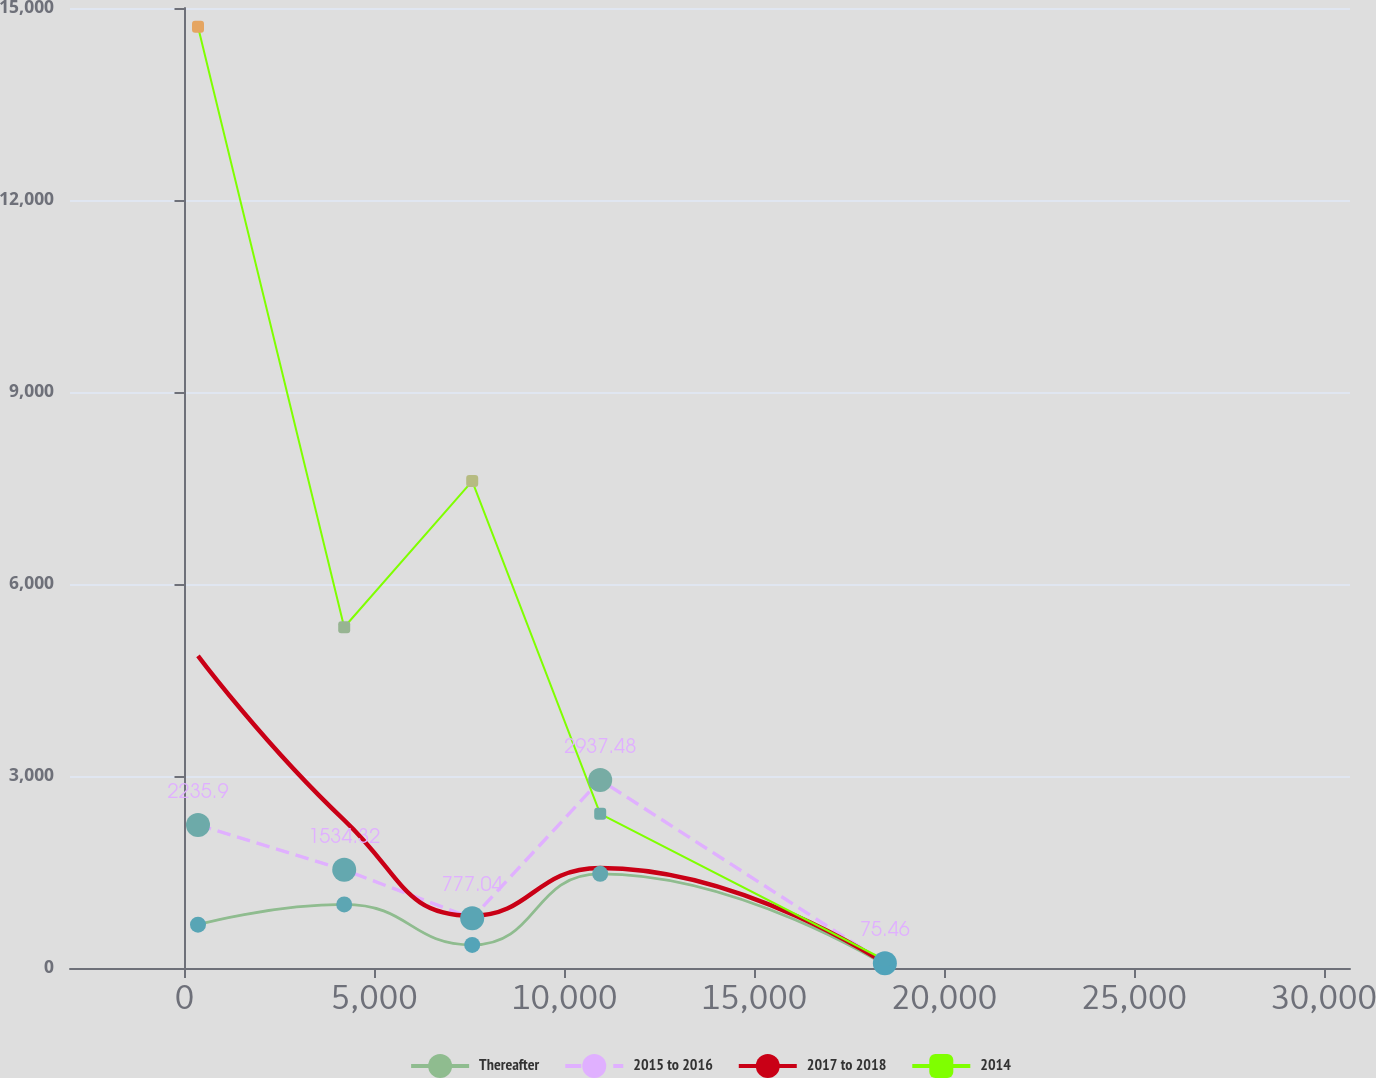<chart> <loc_0><loc_0><loc_500><loc_500><line_chart><ecel><fcel>Thereafter<fcel>2015 to 2016<fcel>2017 to 2018<fcel>2014<nl><fcel>355.63<fcel>677.25<fcel>2235.9<fcel>4877.74<fcel>14707.7<nl><fcel>4205.98<fcel>993.56<fcel>1534.32<fcel>2310.39<fcel>5324.15<nl><fcel>7576.96<fcel>360.94<fcel>777.04<fcel>816.58<fcel>7608.61<nl><fcel>10947.9<fcel>1470.84<fcel>2937.48<fcel>1563.49<fcel>2409.62<nl><fcel>18444.9<fcel>44.63<fcel>75.46<fcel>69.67<fcel>125.16<nl><fcel>34065.4<fcel>3207.75<fcel>7091.25<fcel>7538.72<fcel>22969.8<nl></chart> 